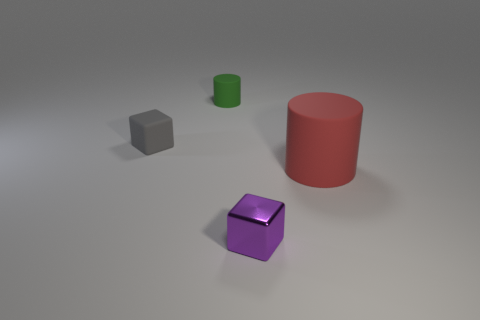Subtract all gray cubes. Subtract all yellow cylinders. How many cubes are left? 1 Subtract all purple cylinders. How many brown cubes are left? 0 Add 3 tiny cyans. How many objects exist? 0 Subtract all large red rubber blocks. Subtract all large matte objects. How many objects are left? 3 Add 3 tiny purple blocks. How many tiny purple blocks are left? 4 Add 1 shiny things. How many shiny things exist? 2 Add 4 small gray cubes. How many objects exist? 8 Subtract all purple cubes. How many cubes are left? 1 Subtract 0 cyan spheres. How many objects are left? 4 Subtract 2 blocks. How many blocks are left? 0 